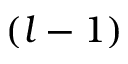Convert formula to latex. <formula><loc_0><loc_0><loc_500><loc_500>( l - 1 )</formula> 